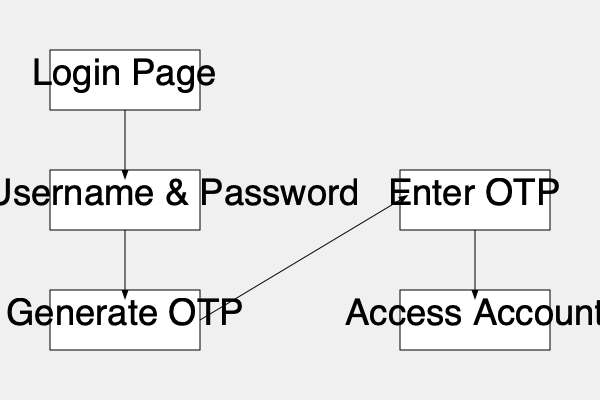In the two-factor authentication process for online banking shown in the flowchart, what step immediately follows the "Enter Username & Password" stage? To answer this question, let's follow the flowchart step-by-step:

1. The process begins at the "Login Page".
2. From the "Login Page", an arrow leads to "Enter Username & Password".
3. After "Enter Username & Password", the next step is clearly indicated by an arrow pointing downwards.
4. This arrow leads to the "Generate OTP" box.
5. OTP stands for One-Time Password, which is a common second factor in two-factor authentication systems.
6. After the OTP is generated, the user would then enter this OTP in the next step.
7. Finally, upon successful OTP entry, the user gains access to their account.

Therefore, the step that immediately follows "Enter Username & Password" is "Generate OTP".
Answer: Generate OTP 